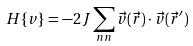Convert formula to latex. <formula><loc_0><loc_0><loc_500><loc_500>H \{ v \} = - 2 { J } \sum _ { n n } \vec { v } ( { \vec { r } } ) \cdot \vec { v } ( { \vec { r } } ^ { \prime } )</formula> 